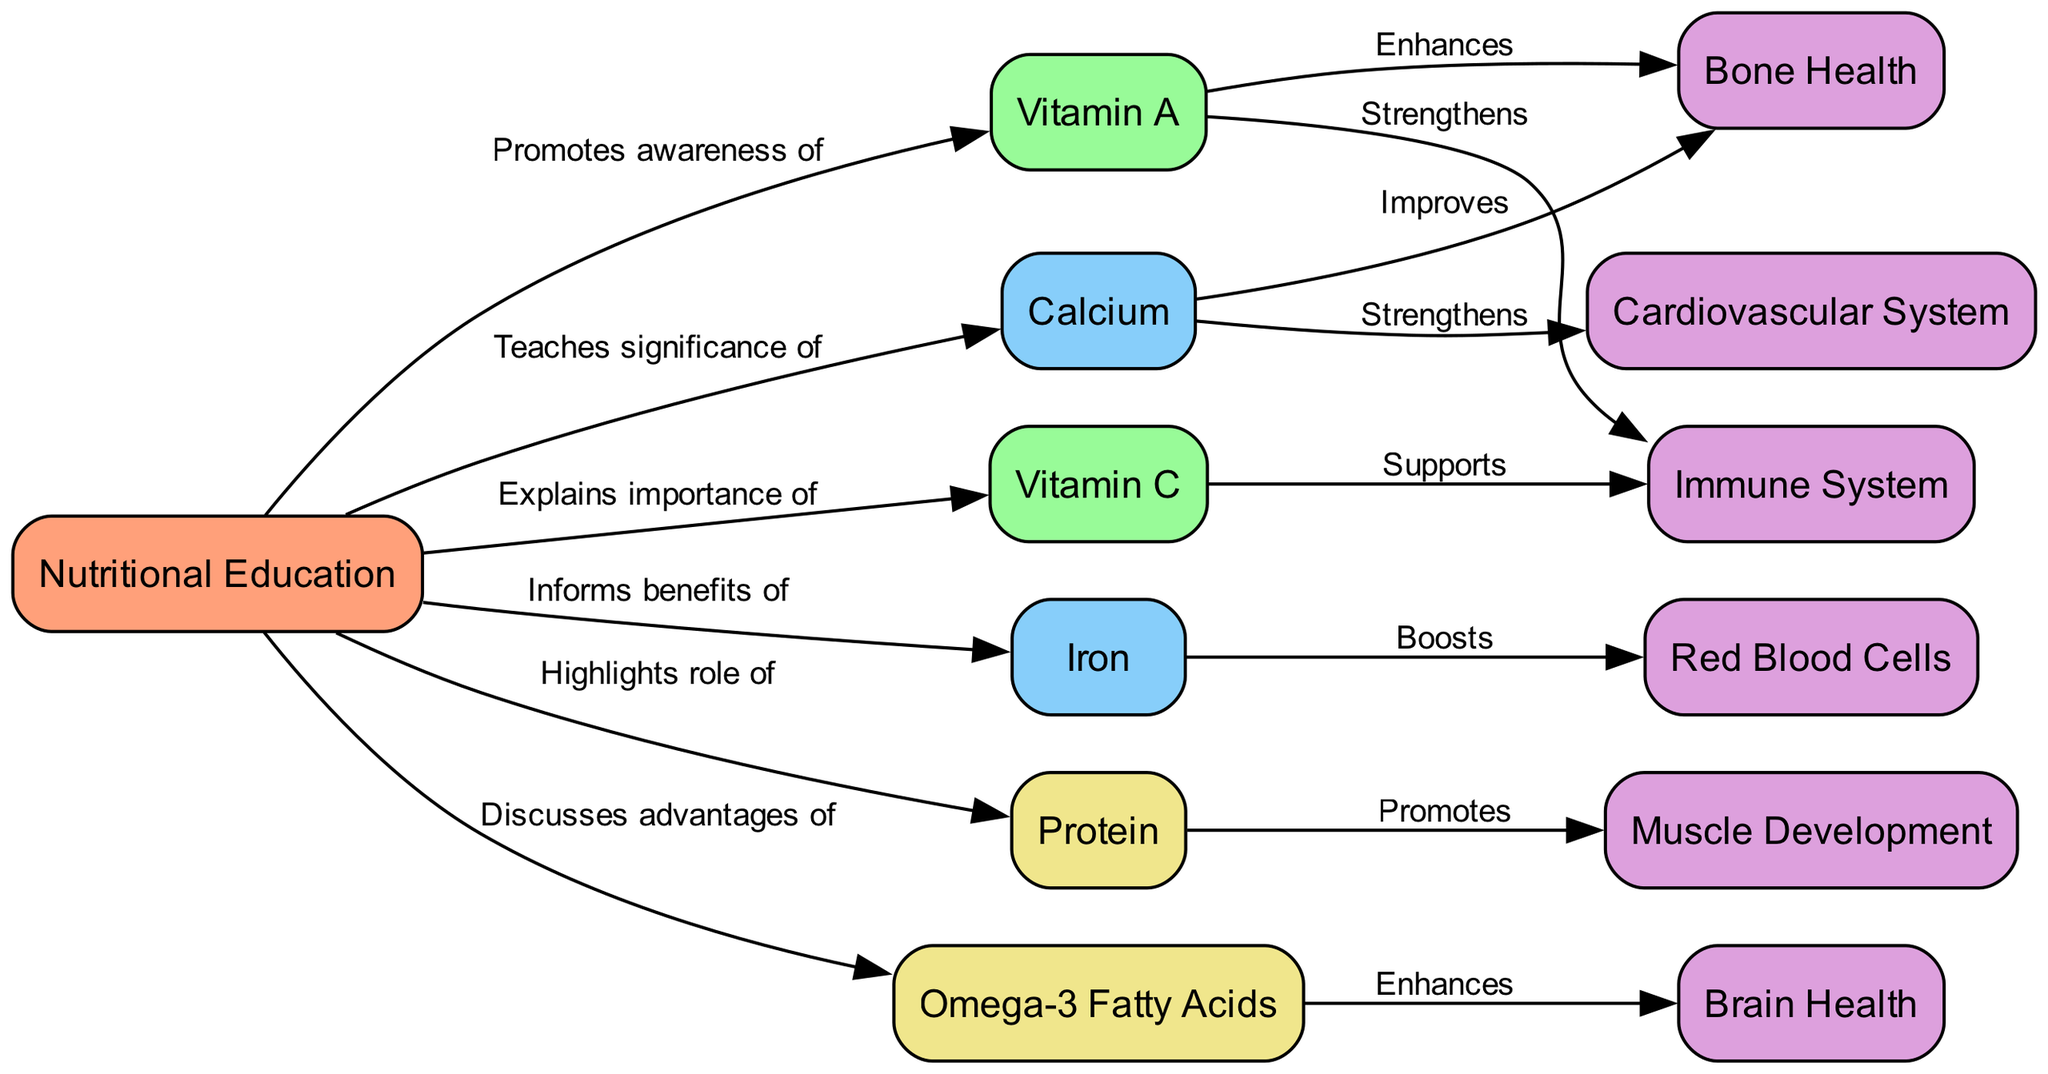What is the first node in the diagram? The first node in the diagram is "Nutritional Education," which is the starting point for the various nutrient connections illustrated throughout the diagram.
Answer: Nutritional Education How many nutrients are connected to the "Nutritional Education" node? There are six nutrients connected to the "Nutritional Education" node: Vitamin A, Vitamin C, Iron, Protein, Omega-3 Fatty Acids, and Calcium, which directly illustrate the effects of nutritional education.
Answer: 6 Which nutrient strengthens the immune system? Vitamin A and Vitamin C both have directed edges indicating they strengthen the immune system, showing the positive effects of these nutrients on this specific body system.
Answer: Vitamin A, Vitamin C What effect does Protein have according to the diagram? The diagram shows that Protein promotes muscle development, establishing a direct relationship between adequate Protein intake and the support of musculature in the body.
Answer: Promotes muscle development What relationship exists between Calcium and Bone Health? The edge shows that Calcium improves bone health, indicating that proper intake of Calcium is essential for maintaining or enhancing the strong structure of bones in the body.
Answer: Improves Which nutrient enhances brain health? Omega-3 Fatty Acids enhance brain health, connecting their intake to cognitive benefits, as depicted in the diagram.
Answer: Omega-3 Fatty Acids How does Iron affect red blood cells? The diagram indicates that Iron boosts red blood cells, showing a direct and important link between Iron intake and the production or maintenance of red blood cells necessary for oxygen transport.
Answer: Boosts What is a potential outcome of teaching the significance of Calcium? Teaching the significance of Calcium in nutritional education leads to improvements in bone health and strengthens the cardiovascular system, highlighting its crucial role in overall health.
Answer: Improvements in bone health, strengthens cardiovascular system What color represents the "Nutritional Education" node in the diagram? The "Nutritional Education" node is represented in light salmon color, distinguishing it from other nodes that represent vitamins and minerals.
Answer: Light Salmon 